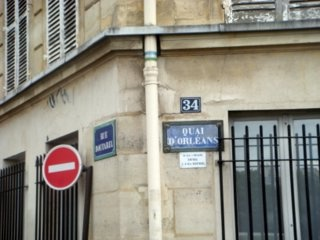Describe the objects in this image and their specific colors. I can see a stop sign in gray, brown, lightgray, and lightpink tones in this image. 